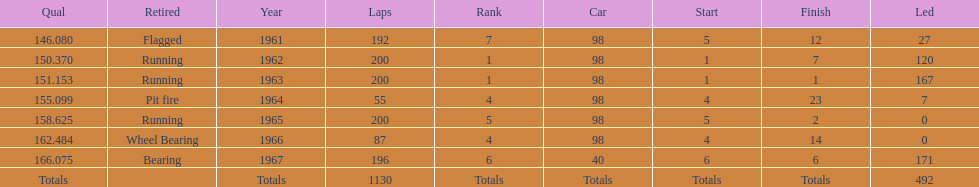How many consecutive years did parnelli place in the top 5? 5. 